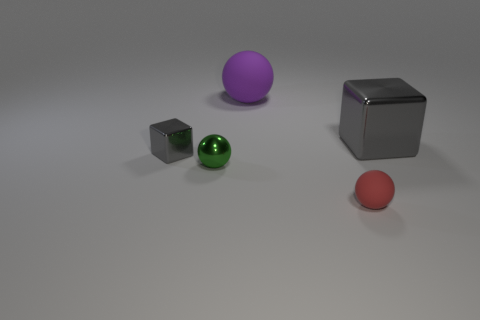There is a large shiny object; does it have the same color as the tiny thing that is behind the small green metal sphere?
Make the answer very short. Yes. There is a big purple thing that is made of the same material as the red object; what shape is it?
Your answer should be very brief. Sphere. How many small matte things are there?
Make the answer very short. 1. How many things are tiny objects that are in front of the small gray shiny object or tiny green things?
Your answer should be very brief. 2. There is a big thing that is right of the red sphere; does it have the same color as the big matte thing?
Provide a short and direct response. No. How many other objects are the same color as the small shiny block?
Provide a succinct answer. 1. How many tiny objects are either red metallic cubes or purple objects?
Provide a short and direct response. 0. Is the number of purple matte balls greater than the number of brown rubber balls?
Ensure brevity in your answer.  Yes. Are the big sphere and the green thing made of the same material?
Your answer should be very brief. No. Are there more purple spheres on the right side of the tiny red rubber sphere than red rubber objects?
Ensure brevity in your answer.  No. 